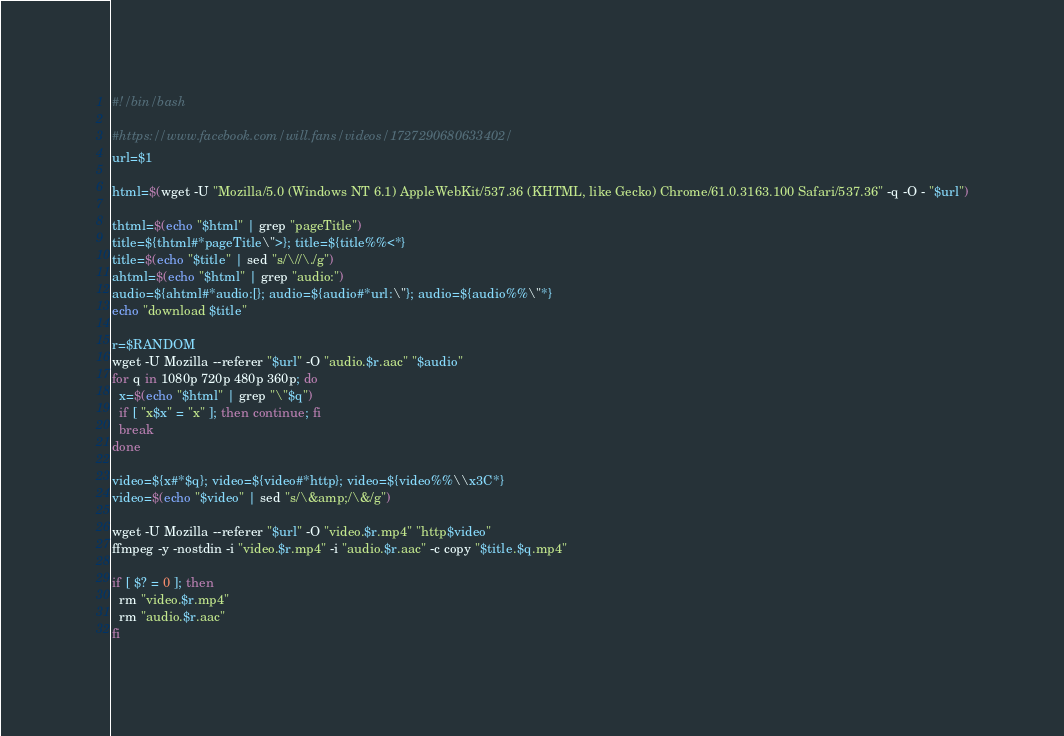Convert code to text. <code><loc_0><loc_0><loc_500><loc_500><_Bash_>#!/bin/bash

#https://www.facebook.com/will.fans/videos/1727290680633402/
url=$1

html=$(wget -U "Mozilla/5.0 (Windows NT 6.1) AppleWebKit/537.36 (KHTML, like Gecko) Chrome/61.0.3163.100 Safari/537.36" -q -O - "$url")

thtml=$(echo "$html" | grep "pageTitle")
title=${thtml#*pageTitle\">}; title=${title%%<*}
title=$(echo "$title" | sed "s/\//\./g")
ahtml=$(echo "$html" | grep "audio:")
audio=${ahtml#*audio:[}; audio=${audio#*url:\"}; audio=${audio%%\"*}
echo "download $title"

r=$RANDOM
wget -U Mozilla --referer "$url" -O "audio.$r.aac" "$audio"
for q in 1080p 720p 480p 360p; do
  x=$(echo "$html" | grep "\"$q")
  if [ "x$x" = "x" ]; then continue; fi
  break
done

video=${x#*$q}; video=${video#*http}; video=${video%%\\x3C*}
video=$(echo "$video" | sed "s/\&amp;/\&/g")

wget -U Mozilla --referer "$url" -O "video.$r.mp4" "http$video"
ffmpeg -y -nostdin -i "video.$r.mp4" -i "audio.$r.aac" -c copy "$title.$q.mp4"

if [ $? = 0 ]; then
  rm "video.$r.mp4"
  rm "audio.$r.aac"
fi

</code> 